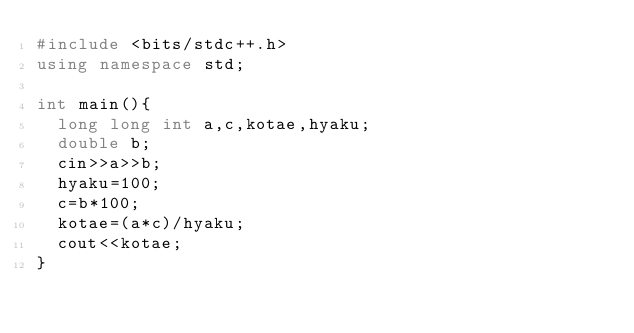Convert code to text. <code><loc_0><loc_0><loc_500><loc_500><_C++_>#include <bits/stdc++.h>
using namespace std;
 
int main(){
  long long int a,c,kotae,hyaku;
  double b;
  cin>>a>>b;
  hyaku=100;
  c=b*100;
  kotae=(a*c)/hyaku;
  cout<<kotae;
}
</code> 